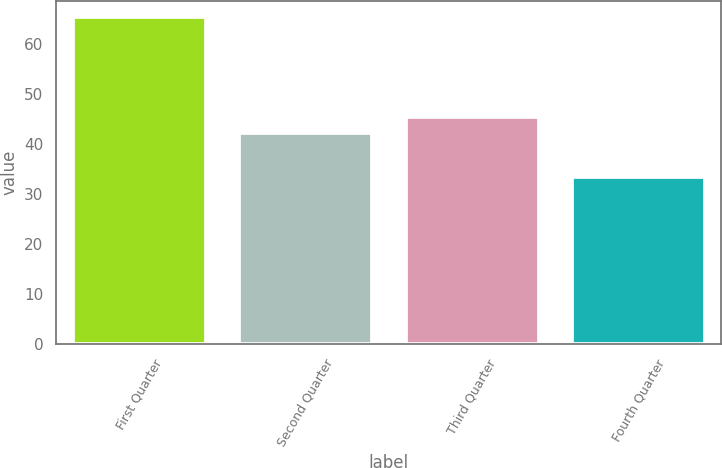<chart> <loc_0><loc_0><loc_500><loc_500><bar_chart><fcel>First Quarter<fcel>Second Quarter<fcel>Third Quarter<fcel>Fourth Quarter<nl><fcel>65.44<fcel>42.24<fcel>45.45<fcel>33.3<nl></chart> 